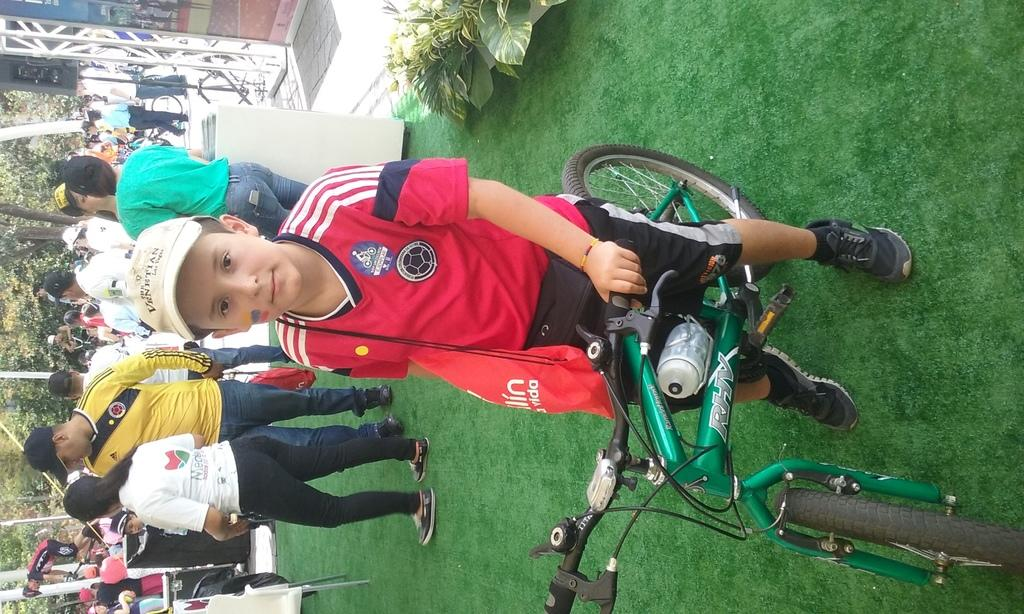Who is the main subject in the image? There is a boy in the image. What is the boy doing in the image? The boy is on a bicycle. What is the position of the bicycle in the image? The bicycle is on the ground. What can be seen in the background of the image? There is a group of people, trees, and some objects in the background of the image. What type of worm can be seen crawling on the boy's finger in the image? There is no worm present in the image, nor is there any indication of a worm crawling on the boy's finger. 